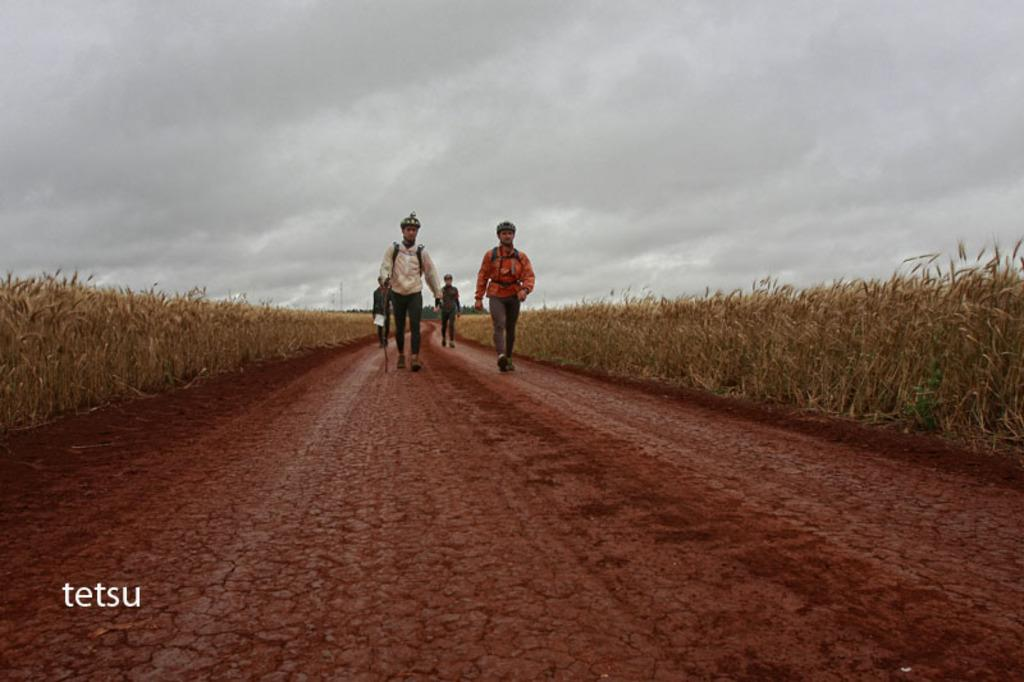What are the people in the image doing? There are persons walking in the image. What can be seen on the sides of the image? There are dried weeds on the right and left sides of the image. What is visible at the top of the image? The sky is visible at the top of the image. What is the condition of the sky in the image? The sky is cloudy in the image. What type of substance is being smoked through the pipe in the image? There is no pipe or substance present in the image. Can you tell me how many turkeys are visible in the image? There are no turkeys visible in the image. 